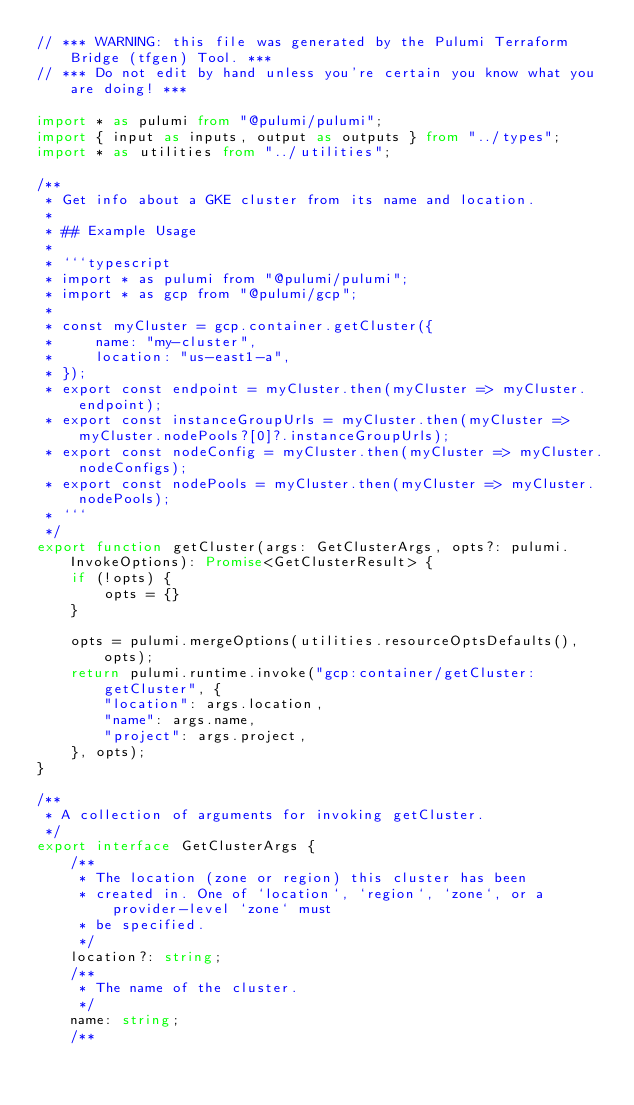Convert code to text. <code><loc_0><loc_0><loc_500><loc_500><_TypeScript_>// *** WARNING: this file was generated by the Pulumi Terraform Bridge (tfgen) Tool. ***
// *** Do not edit by hand unless you're certain you know what you are doing! ***

import * as pulumi from "@pulumi/pulumi";
import { input as inputs, output as outputs } from "../types";
import * as utilities from "../utilities";

/**
 * Get info about a GKE cluster from its name and location.
 *
 * ## Example Usage
 *
 * ```typescript
 * import * as pulumi from "@pulumi/pulumi";
 * import * as gcp from "@pulumi/gcp";
 *
 * const myCluster = gcp.container.getCluster({
 *     name: "my-cluster",
 *     location: "us-east1-a",
 * });
 * export const endpoint = myCluster.then(myCluster => myCluster.endpoint);
 * export const instanceGroupUrls = myCluster.then(myCluster => myCluster.nodePools?[0]?.instanceGroupUrls);
 * export const nodeConfig = myCluster.then(myCluster => myCluster.nodeConfigs);
 * export const nodePools = myCluster.then(myCluster => myCluster.nodePools);
 * ```
 */
export function getCluster(args: GetClusterArgs, opts?: pulumi.InvokeOptions): Promise<GetClusterResult> {
    if (!opts) {
        opts = {}
    }

    opts = pulumi.mergeOptions(utilities.resourceOptsDefaults(), opts);
    return pulumi.runtime.invoke("gcp:container/getCluster:getCluster", {
        "location": args.location,
        "name": args.name,
        "project": args.project,
    }, opts);
}

/**
 * A collection of arguments for invoking getCluster.
 */
export interface GetClusterArgs {
    /**
     * The location (zone or region) this cluster has been
     * created in. One of `location`, `region`, `zone`, or a provider-level `zone` must
     * be specified.
     */
    location?: string;
    /**
     * The name of the cluster.
     */
    name: string;
    /**</code> 